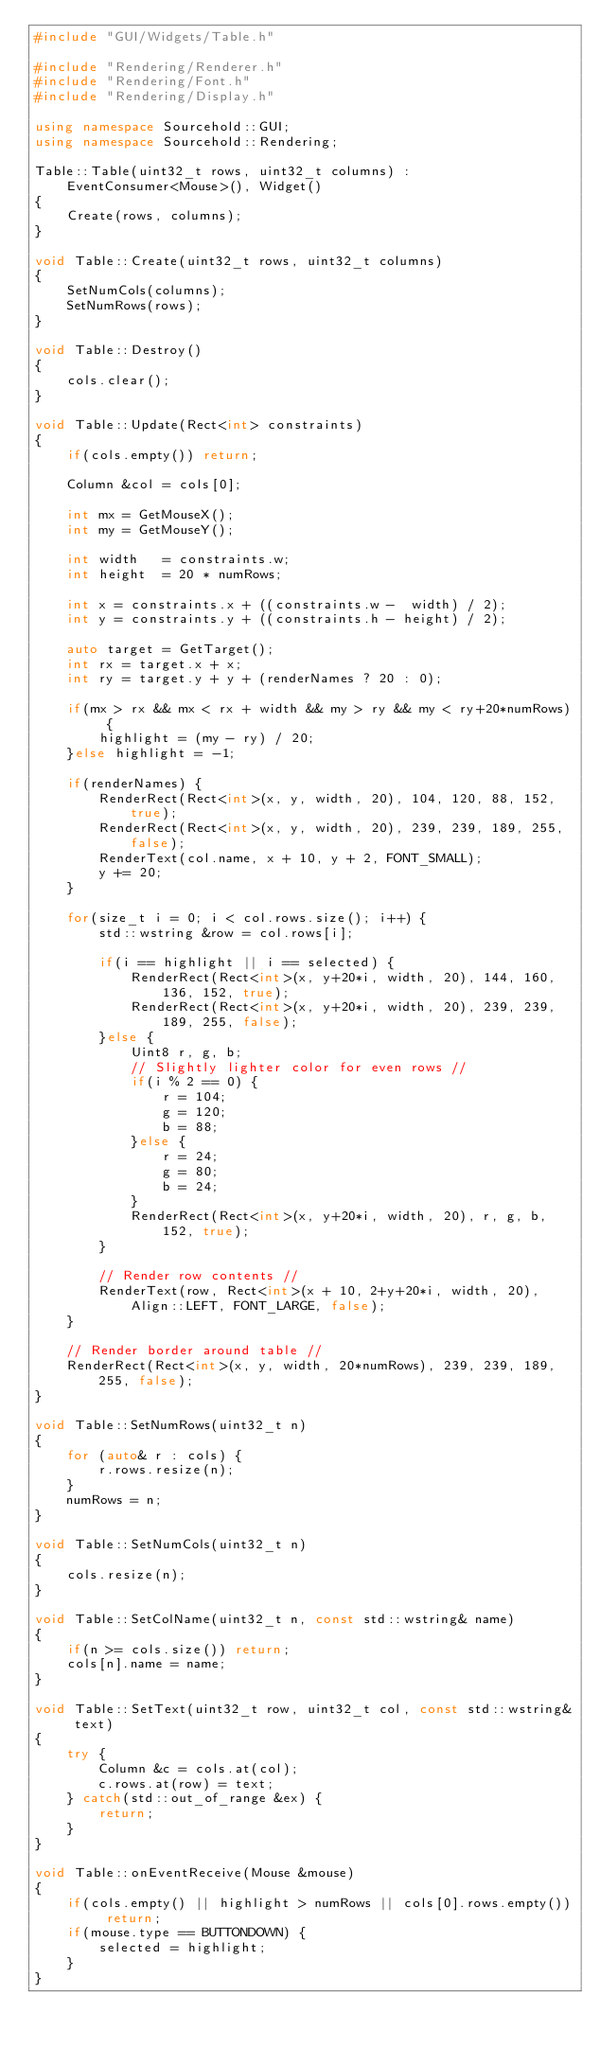<code> <loc_0><loc_0><loc_500><loc_500><_C++_>#include "GUI/Widgets/Table.h"

#include "Rendering/Renderer.h"
#include "Rendering/Font.h"
#include "Rendering/Display.h"

using namespace Sourcehold::GUI;
using namespace Sourcehold::Rendering;

Table::Table(uint32_t rows, uint32_t columns) :
    EventConsumer<Mouse>(), Widget()
{
    Create(rows, columns);
}

void Table::Create(uint32_t rows, uint32_t columns)
{
    SetNumCols(columns);
    SetNumRows(rows);
}

void Table::Destroy()
{
    cols.clear();
}

void Table::Update(Rect<int> constraints)
{
    if(cols.empty()) return;

    Column &col = cols[0];

    int mx = GetMouseX();
    int my = GetMouseY();

    int width   = constraints.w;
    int height  = 20 * numRows;

    int x = constraints.x + ((constraints.w -  width) / 2);
    int y = constraints.y + ((constraints.h - height) / 2);

    auto target = GetTarget();
    int rx = target.x + x;
    int ry = target.y + y + (renderNames ? 20 : 0);

    if(mx > rx && mx < rx + width && my > ry && my < ry+20*numRows) {
        highlight = (my - ry) / 20;
    }else highlight = -1;

    if(renderNames) {
        RenderRect(Rect<int>(x, y, width, 20), 104, 120, 88, 152, true);
        RenderRect(Rect<int>(x, y, width, 20), 239, 239, 189, 255, false);
        RenderText(col.name, x + 10, y + 2, FONT_SMALL);
        y += 20;
    }

    for(size_t i = 0; i < col.rows.size(); i++) {
        std::wstring &row = col.rows[i];

        if(i == highlight || i == selected) {
            RenderRect(Rect<int>(x, y+20*i, width, 20), 144, 160, 136, 152, true);
            RenderRect(Rect<int>(x, y+20*i, width, 20), 239, 239, 189, 255, false);
        }else {
            Uint8 r, g, b;
            // Slightly lighter color for even rows //
            if(i % 2 == 0) {
                r = 104;
                g = 120;
                b = 88;
            }else {
                r = 24;
                g = 80;
                b = 24;
            }
            RenderRect(Rect<int>(x, y+20*i, width, 20), r, g, b, 152, true);
        }

        // Render row contents //
        RenderText(row, Rect<int>(x + 10, 2+y+20*i, width, 20), Align::LEFT, FONT_LARGE, false);
    }

    // Render border around table //
    RenderRect(Rect<int>(x, y, width, 20*numRows), 239, 239, 189, 255, false);
}

void Table::SetNumRows(uint32_t n)
{
    for (auto& r : cols) {
        r.rows.resize(n);
    }
    numRows = n;
}

void Table::SetNumCols(uint32_t n)
{
    cols.resize(n);
}

void Table::SetColName(uint32_t n, const std::wstring& name)
{
    if(n >= cols.size()) return;
    cols[n].name = name;
}

void Table::SetText(uint32_t row, uint32_t col, const std::wstring& text)
{
    try {
        Column &c = cols.at(col);
        c.rows.at(row) = text;
    } catch(std::out_of_range &ex) {
        return;
    }
}

void Table::onEventReceive(Mouse &mouse)
{
    if(cols.empty() || highlight > numRows || cols[0].rows.empty()) return;
    if(mouse.type == BUTTONDOWN) {
        selected = highlight;
    }
}
</code> 